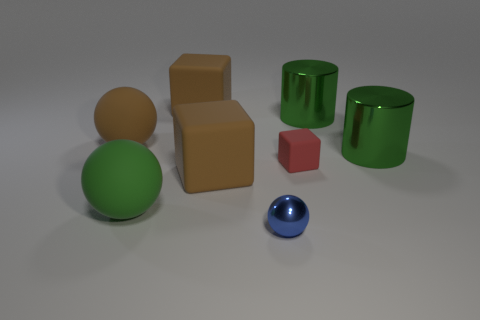Subtract all yellow spheres. How many brown blocks are left? 2 Add 2 big blue rubber balls. How many objects exist? 10 Subtract all blocks. How many objects are left? 5 Add 6 metal objects. How many metal objects exist? 9 Subtract 1 brown balls. How many objects are left? 7 Subtract all blue matte cylinders. Subtract all small cubes. How many objects are left? 7 Add 8 green matte things. How many green matte things are left? 9 